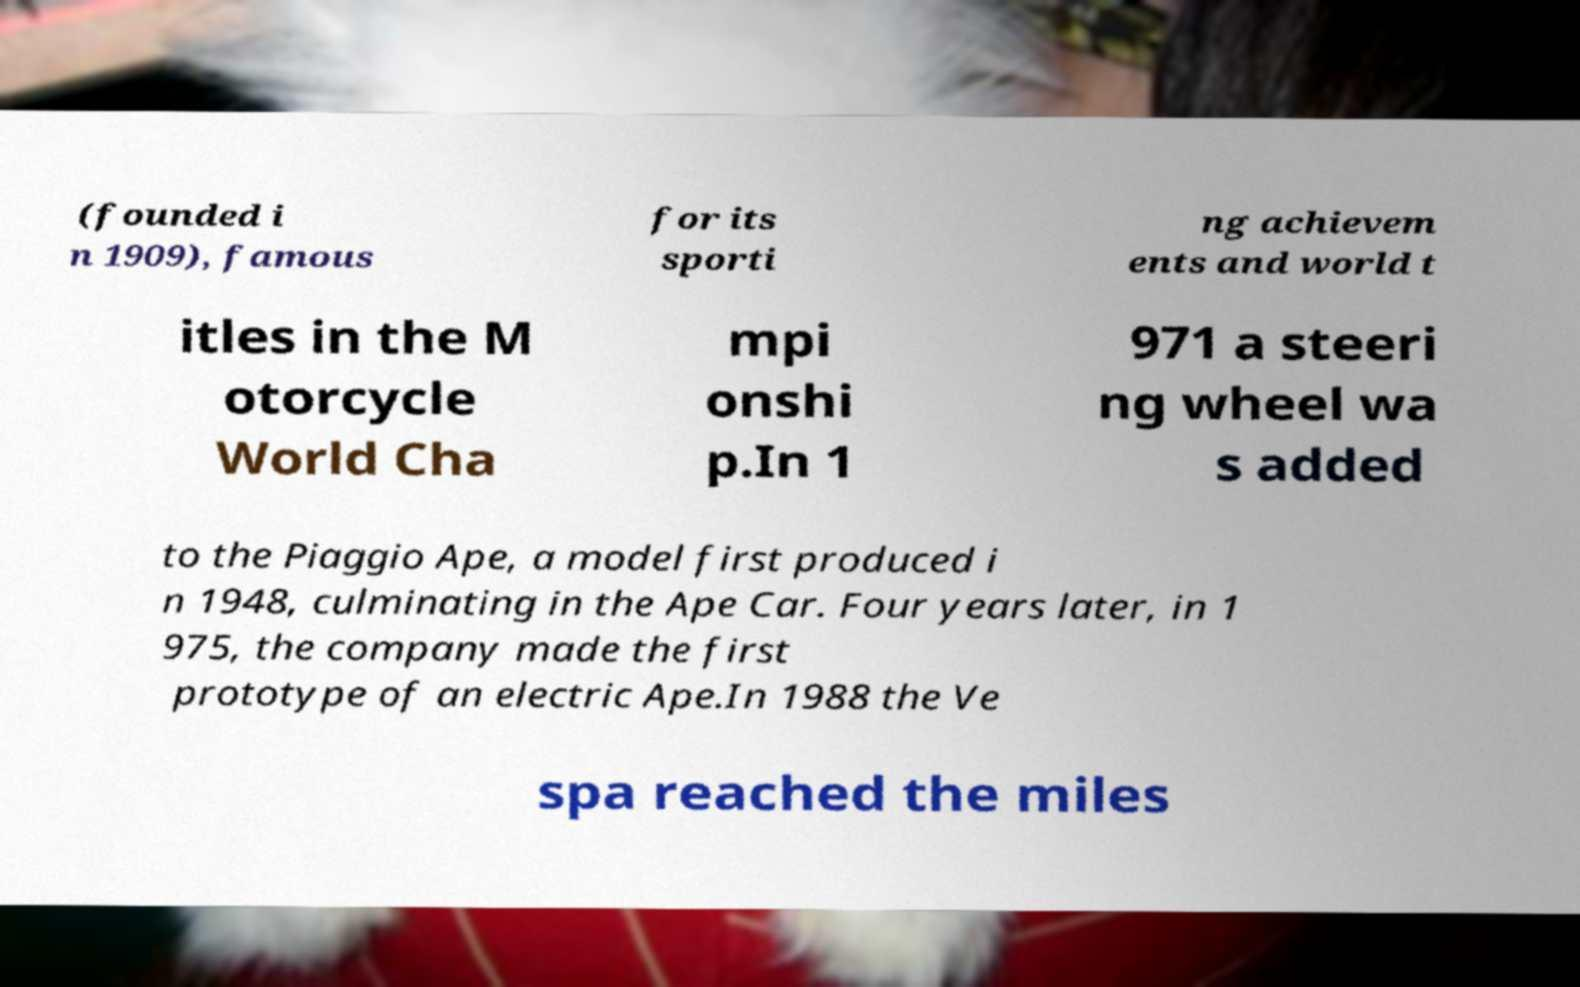Please read and relay the text visible in this image. What does it say? (founded i n 1909), famous for its sporti ng achievem ents and world t itles in the M otorcycle World Cha mpi onshi p.In 1 971 a steeri ng wheel wa s added to the Piaggio Ape, a model first produced i n 1948, culminating in the Ape Car. Four years later, in 1 975, the company made the first prototype of an electric Ape.In 1988 the Ve spa reached the miles 